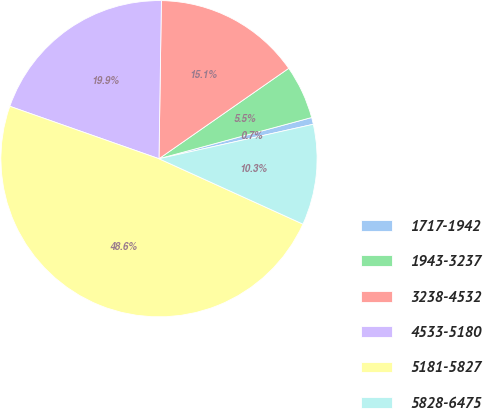Convert chart. <chart><loc_0><loc_0><loc_500><loc_500><pie_chart><fcel>1717-1942<fcel>1943-3237<fcel>3238-4532<fcel>4533-5180<fcel>5181-5827<fcel>5828-6475<nl><fcel>0.7%<fcel>5.49%<fcel>15.07%<fcel>19.86%<fcel>48.59%<fcel>10.28%<nl></chart> 